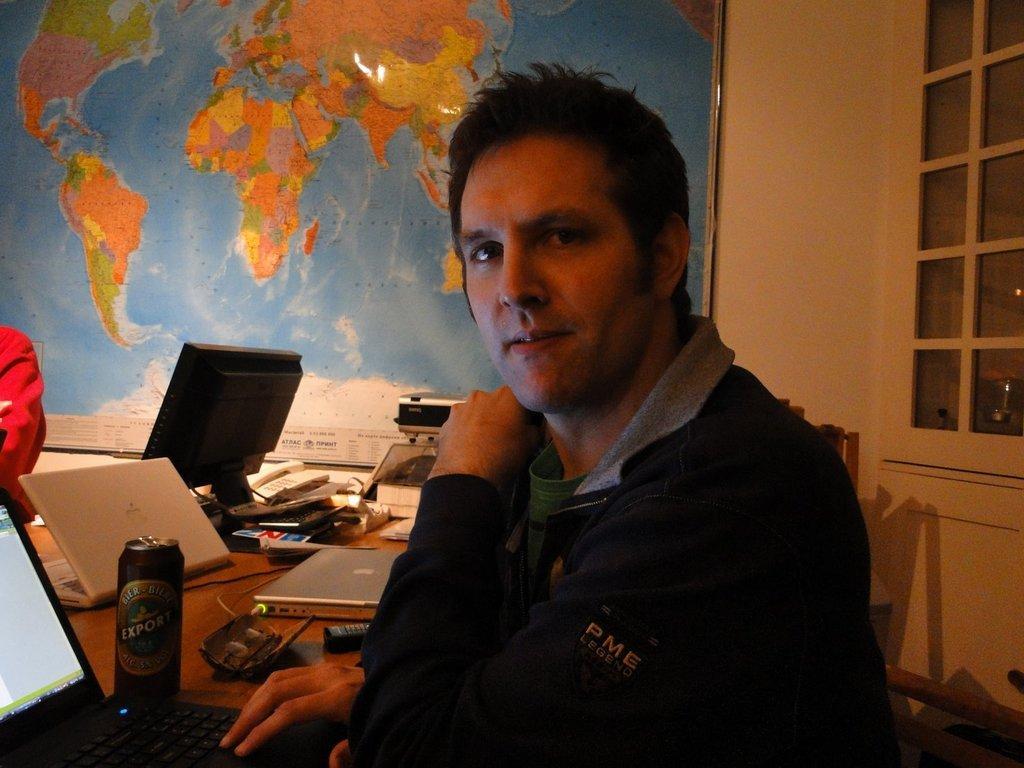Please provide a concise description of this image. in this picture a person is sitting on a chair, and in front of him here is a table he is working on the laptop, and here is the tin and here is the computer, and here are some objects and there is world map on the wall, and here is a glass. 